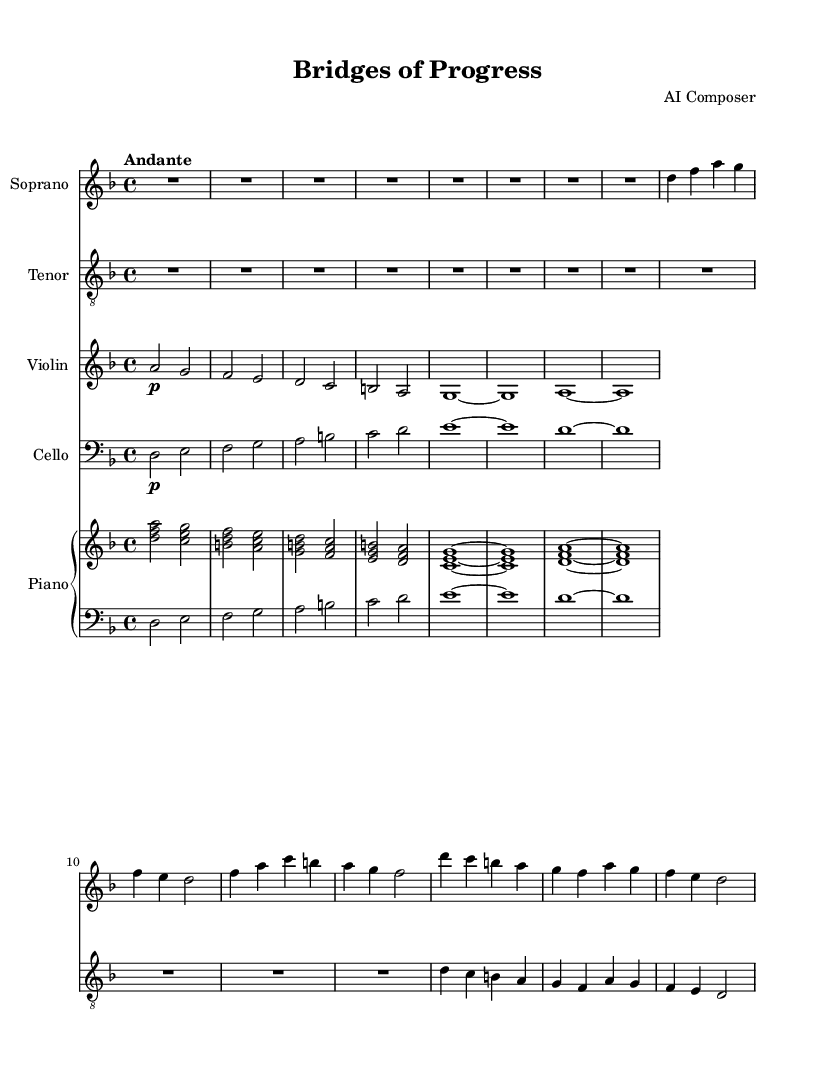What is the key signature of this music? The key signature is indicated at the beginning of the staff. Here, it shows two flats, which corresponds to the key of D minor.
Answer: D minor What is the time signature of this music? The time signature is shown following the key signature. It is indicated as "4/4", which means there are four beats in a measure.
Answer: 4/4 What is the tempo marking of this music? The tempo marking is typically found near the beginning of the score, indicating the speed. In this piece, it reads "Andante," which suggests a moderately slow speed.
Answer: Andante How many measures are in the soprano part? To find the number of measures, we count the vertical lines (bar lines) in the soprano part. There are eight measures in total present in the given excerpt.
Answer: Eight In which clef is the tenor part written? The clef for the tenor part is shown at the beginning of the staff, and it indicates that it is written in the treble clef shifted an octave lower, commonly referred to as "treble_8".
Answer: Treble 8 Which instruments are included in this opera score? The score includes the soprano, tenor, violin, cello, and a piano staff made up of right and left hand parts, typically indicating a piano arrangement.
Answer: Soprano, tenor, violin, cello, piano What is the dynamic marking for the violin part? The dynamic marking for the violin part is indicated by the symbol 'p', which stands for 'piano', meaning to play softly.
Answer: Piano 